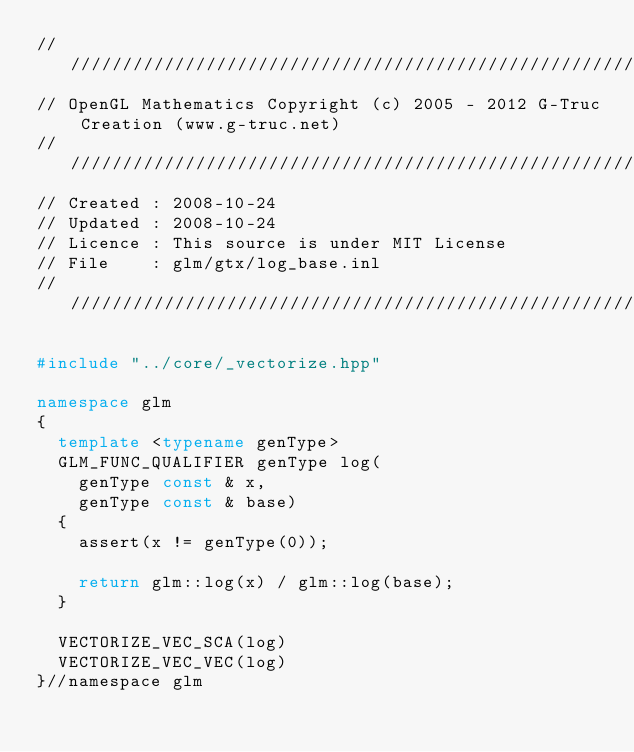<code> <loc_0><loc_0><loc_500><loc_500><_C++_>///////////////////////////////////////////////////////////////////////////////////////////////////
// OpenGL Mathematics Copyright (c) 2005 - 2012 G-Truc Creation (www.g-truc.net)
///////////////////////////////////////////////////////////////////////////////////////////////////
// Created : 2008-10-24
// Updated : 2008-10-24
// Licence : This source is under MIT License
// File    : glm/gtx/log_base.inl
///////////////////////////////////////////////////////////////////////////////////////////////////

#include "../core/_vectorize.hpp"

namespace glm
{
	template <typename genType> 
	GLM_FUNC_QUALIFIER genType log(
		genType const & x, 
		genType const & base)
	{
		assert(x != genType(0));

		return glm::log(x) / glm::log(base);
	}

	VECTORIZE_VEC_SCA(log)
	VECTORIZE_VEC_VEC(log)
}//namespace glm
</code> 